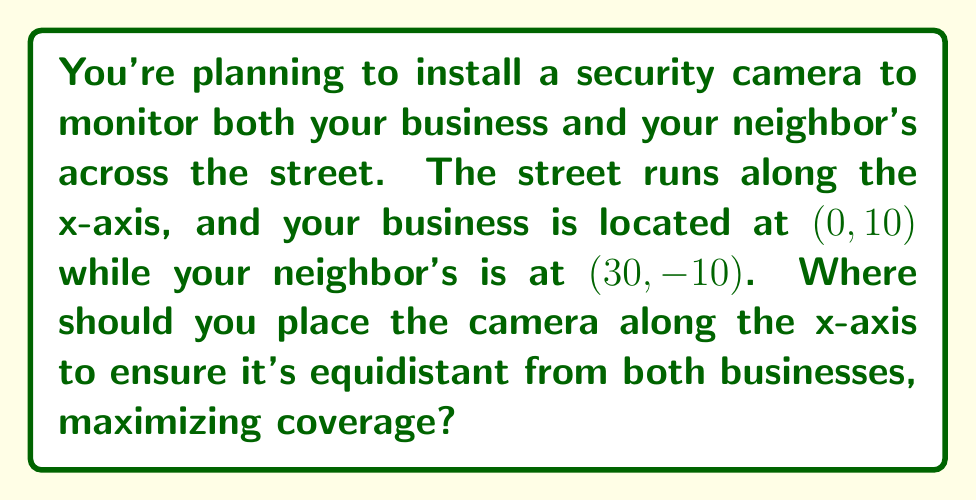Give your solution to this math problem. Let's approach this step-by-step:

1) We need to find a point $(x, 0)$ on the x-axis that is equidistant from $(0, 10)$ and $(30, -10)$.

2) We can use the distance formula to set up an equation:
   $$\sqrt{(x-0)^2 + (0-10)^2} = \sqrt{(x-30)^2 + (0-(-10))^2}$$

3) Simplify:
   $$\sqrt{x^2 + 100} = \sqrt{(x-30)^2 + 100}$$

4) Square both sides:
   $$x^2 + 100 = (x-30)^2 + 100$$

5) Expand the right side:
   $$x^2 + 100 = x^2 - 60x + 900 + 100$$

6) Simplify:
   $$x^2 + 100 = x^2 - 60x + 1000$$

7) Subtract $x^2$ and 100 from both sides:
   $$0 = -60x + 900$$

8) Add 60x to both sides:
   $$60x = 900$$

9) Divide both sides by 60:
   $$x = 15$$

Therefore, the optimal location for the security camera is at (15, 0) on the x-axis.

[asy]
unitsize(4mm);
draw((-5,0)--(35,0),Arrow);
draw((0,-15)--(0,15),Arrow);
dot((0,10));
dot((30,-10));
dot((15,0));
label("Your business (0, 10)", (0,10), N);
label("Neighbor's business (30, -10)", (30,-10), S);
label("Camera (15, 0)", (15,0), S);
label("x", (35,0), E);
label("y", (0,15), N);
[/asy]
Answer: (15, 0) 